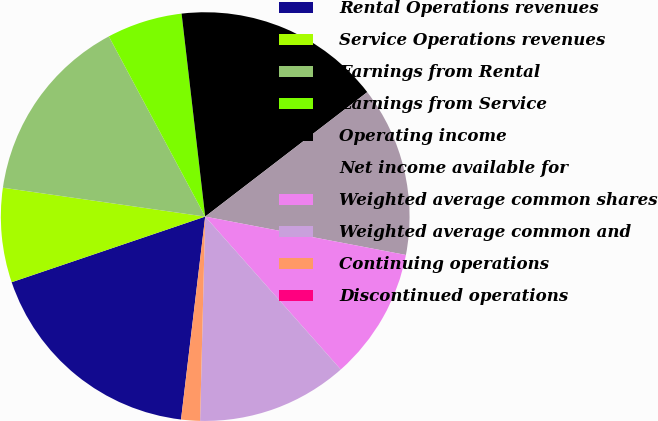Convert chart. <chart><loc_0><loc_0><loc_500><loc_500><pie_chart><fcel>Rental Operations revenues<fcel>Service Operations revenues<fcel>Earnings from Rental<fcel>Earnings from Service<fcel>Operating income<fcel>Net income available for<fcel>Weighted average common shares<fcel>Weighted average common and<fcel>Continuing operations<fcel>Discontinued operations<nl><fcel>17.91%<fcel>7.46%<fcel>14.93%<fcel>5.97%<fcel>16.42%<fcel>13.43%<fcel>10.45%<fcel>11.94%<fcel>1.49%<fcel>0.0%<nl></chart> 